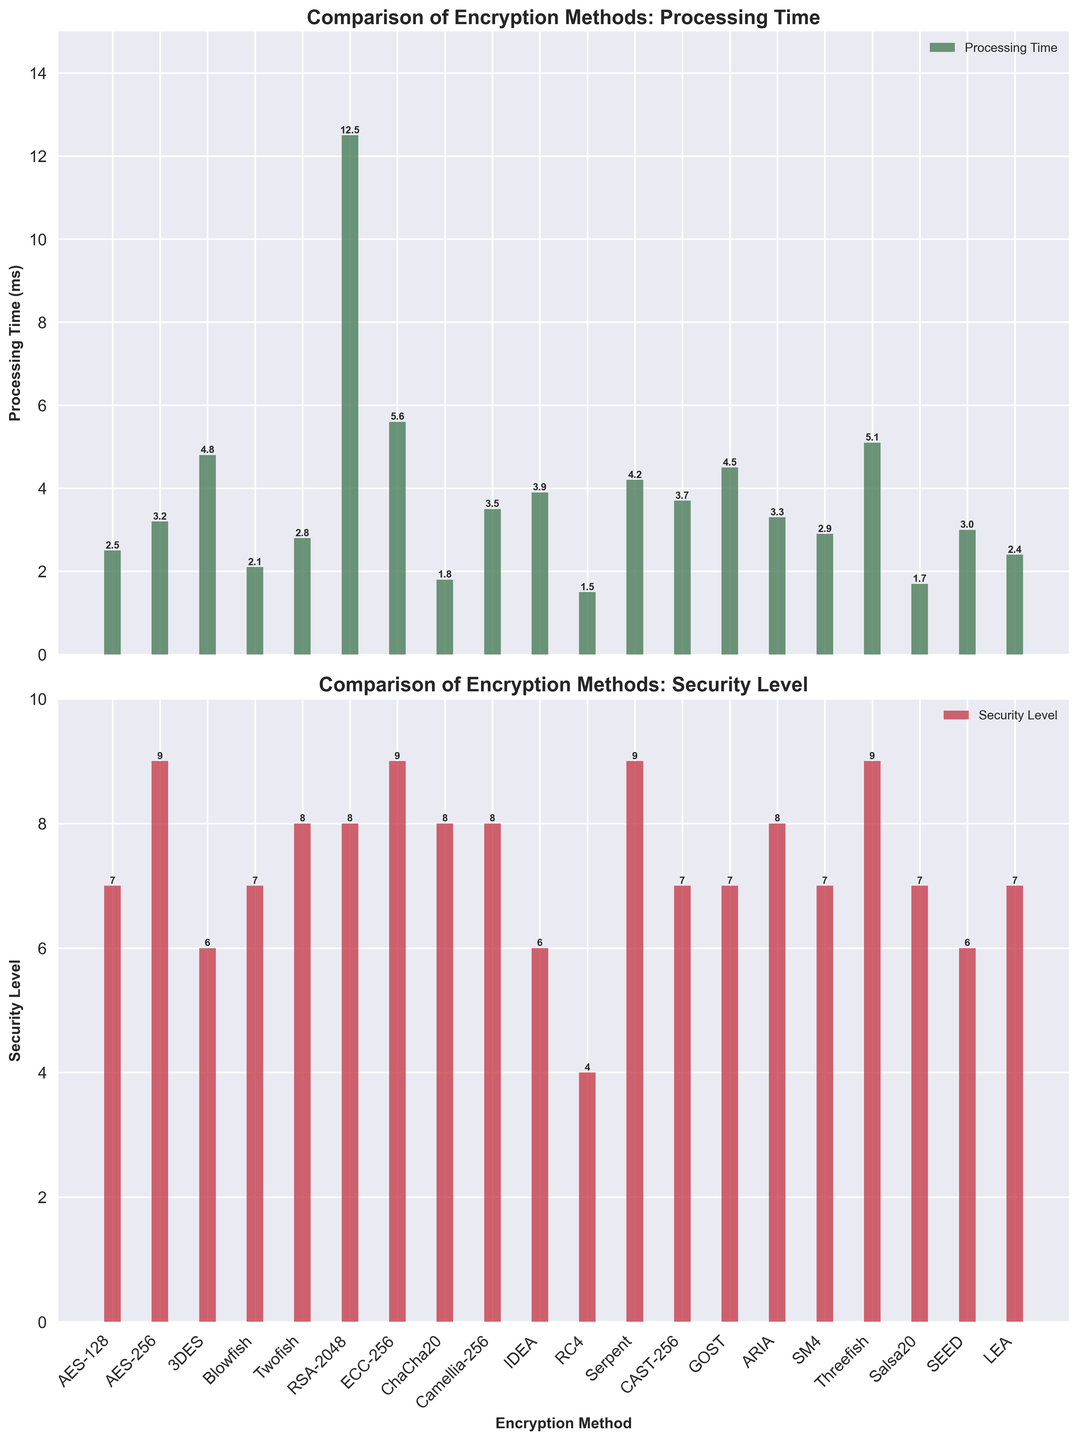Which encryption method has the shortest processing time? Looking at the first subplot (Processing Time), the shortest bar represents the encryption method with the shortest processing time.
Answer: RC4 Which encryption method has the highest security level? Examining the second subplot (Security Level), the tallest bar corresponds to the encryption method with the highest security level.
Answer: AES-256, ECC-256, Serpent, and Threefish How does AES-256 compare to ChaCha20 in terms of processing time and security level? AES-256 has a processing time of 3.2 ms and a security level of 9; ChaCha20 has a processing time of 1.8 ms and a security level of 8.
Answer: AES-256 is slower but more secure What is the difference in processing time between the fastest and slowest encryption methods? The fastest method is RC4 (1.5 ms), and the slowest is RSA-2048 (12.5 ms). The difference is 12.5 - 1.5.
Answer: 11 ms Which encryption methods have a security level of 7? Observing the second subplot (Security Level), the bars that reach the value of 7 correspond to the methods: AES-128, Blowfish, CAST-256, GOST, SM4, Salsa20, and LEA.
Answer: AES-128, Blowfish, CAST-256, GOST, SM4, Salsa20, LEA How many encryption methods have processing times less than 3 ms? Counting the bars in the first subplot (Processing Time) that are less than 3 ms, we find: AES-128, Blowfish, ChaCha20, RC4, Salsa20, and LEA.
Answer: 6 What is the average processing time for all encryption methods? Sum all processing times and divide by the number of methods: (2.5 + 3.2 + 4.8 + 2.1 + 2.8 + 12.5 + 5.6 + 1.8 + 3.5 + 3.9 + 1.5 + 4.2 + 3.7 + 4.5 + 3.3 + 2.9 + 5.1 + 1.7 + 3.0 + 2.4) / 20 = 3.77.
Answer: 3.77 ms Are there any encryption methods with exactly the same processing time? Checking the first subplot (Processing Time) for bars of equal height, none are exactly the same.
Answer: No Which has a greater impact on processing time: AES-128 or Blowfish? Comparing the height of the bars in the first subplot (Processing Time): AES-128 corresponds to 2.5 ms, Blowfish to 2.1 ms. Blowfish has a shorter processing time.
Answer: Blowfish What is the median security level of the encryption methods? Listing security levels: 4, 6, 6, 6, 6, 7, 7, 7, 7, 7, 7, 8, 8, 8, 8, 8, 9, 9, 9, 9, the median is the average of the 10th and 11th values: (7+7)/2 = 7
Answer: 7 